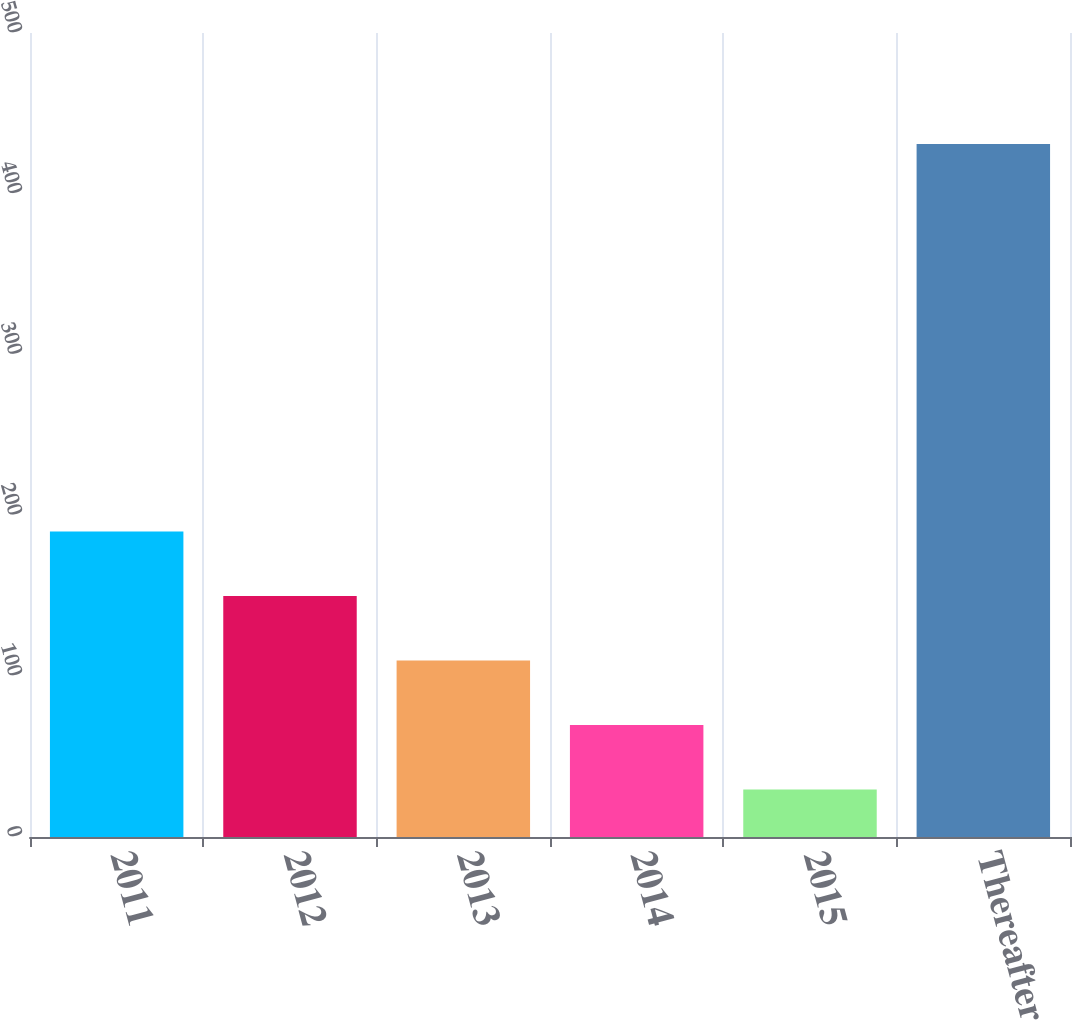<chart> <loc_0><loc_0><loc_500><loc_500><bar_chart><fcel>2011<fcel>2012<fcel>2013<fcel>2014<fcel>2015<fcel>Thereafter<nl><fcel>190.06<fcel>149.92<fcel>109.78<fcel>69.64<fcel>29.5<fcel>430.9<nl></chart> 